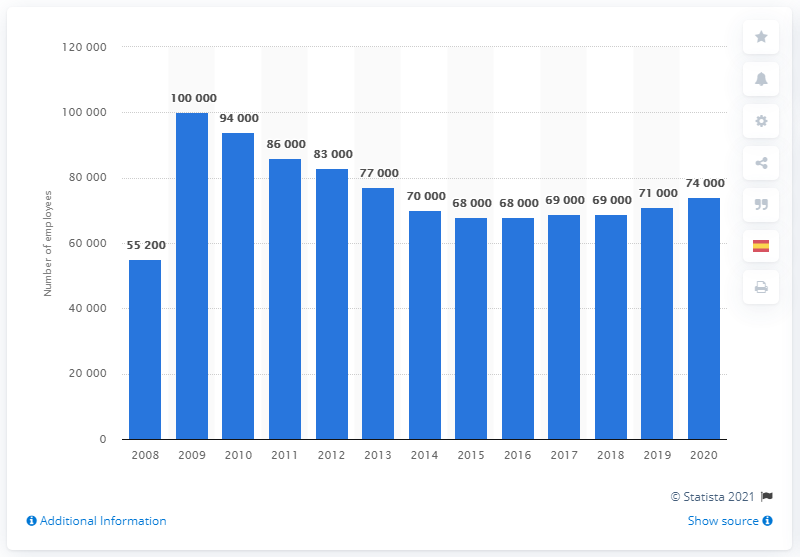What might have caused the fluctuations in Merck & Co.'s employee numbers? The fluctuations in employee numbers could be attributed to a variety of factors such as mergers and acquisitions, strategic business decisions, restructuring, the impact of global economic conditions, and changes in the pharmaceutical industry. Each peak and trough in the chart potentially corresponds to specific events or company initiatives that led to a change in workforce size. 